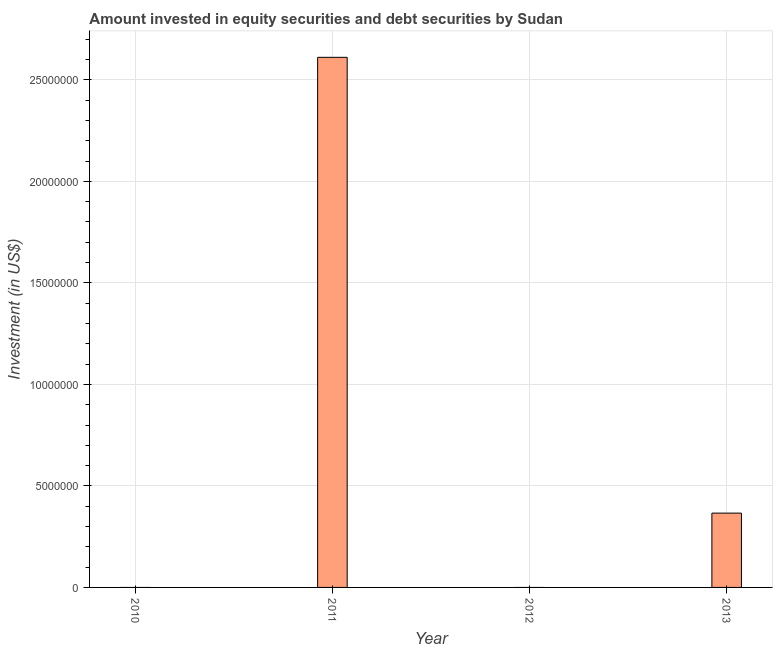Does the graph contain any zero values?
Offer a terse response. Yes. What is the title of the graph?
Your answer should be compact. Amount invested in equity securities and debt securities by Sudan. What is the label or title of the Y-axis?
Keep it short and to the point. Investment (in US$). What is the portfolio investment in 2012?
Offer a terse response. 0. Across all years, what is the maximum portfolio investment?
Your answer should be compact. 2.61e+07. Across all years, what is the minimum portfolio investment?
Make the answer very short. 0. What is the sum of the portfolio investment?
Give a very brief answer. 2.98e+07. What is the difference between the portfolio investment in 2011 and 2013?
Your response must be concise. 2.25e+07. What is the average portfolio investment per year?
Your response must be concise. 7.44e+06. What is the median portfolio investment?
Ensure brevity in your answer.  1.83e+06. In how many years, is the portfolio investment greater than 3000000 US$?
Your answer should be very brief. 2. What is the difference between the highest and the lowest portfolio investment?
Give a very brief answer. 2.61e+07. How many bars are there?
Offer a terse response. 2. Are all the bars in the graph horizontal?
Offer a very short reply. No. Are the values on the major ticks of Y-axis written in scientific E-notation?
Keep it short and to the point. No. What is the Investment (in US$) in 2010?
Offer a very short reply. 0. What is the Investment (in US$) in 2011?
Provide a succinct answer. 2.61e+07. What is the Investment (in US$) of 2012?
Your response must be concise. 0. What is the Investment (in US$) of 2013?
Offer a terse response. 3.66e+06. What is the difference between the Investment (in US$) in 2011 and 2013?
Your answer should be very brief. 2.25e+07. What is the ratio of the Investment (in US$) in 2011 to that in 2013?
Make the answer very short. 7.13. 